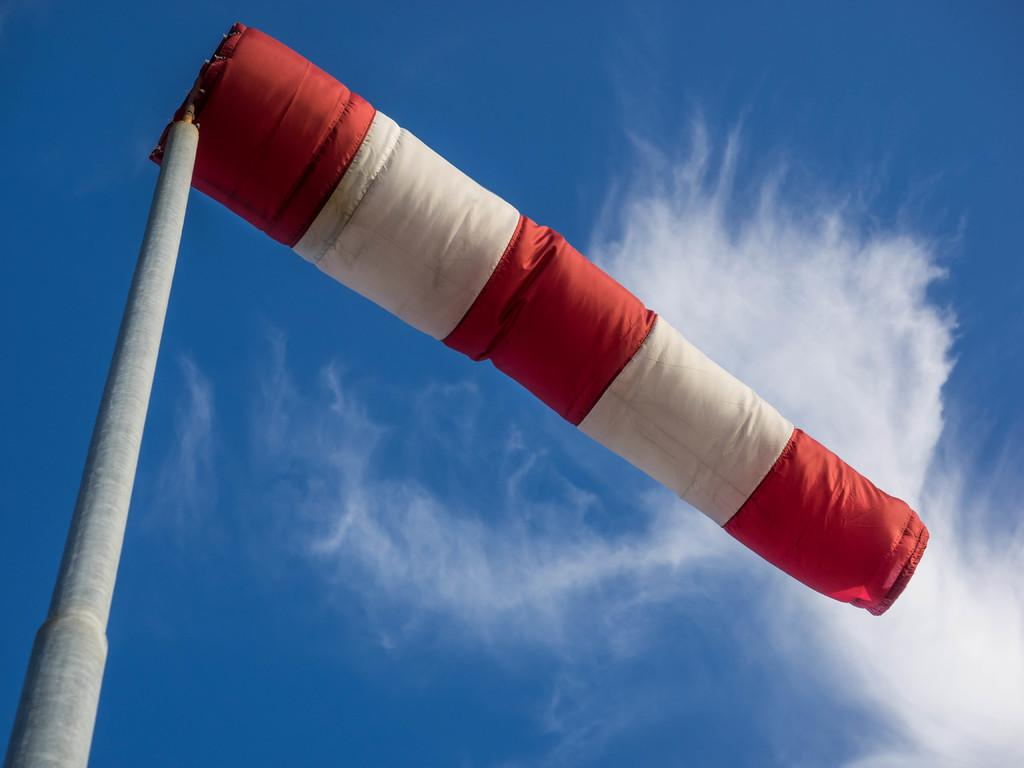What object can be seen in the image related to wind or weather? There is a windsock in the image. What can be seen in the sky in the image? There are clouds visible in the sky. Is there any quicksand visible in the image? No, there is no quicksand present in the image. Can you tell me how many zippers are on the windsock in the image? There are no zippers on the windsock in the image, as it is a simple fabric tube. 